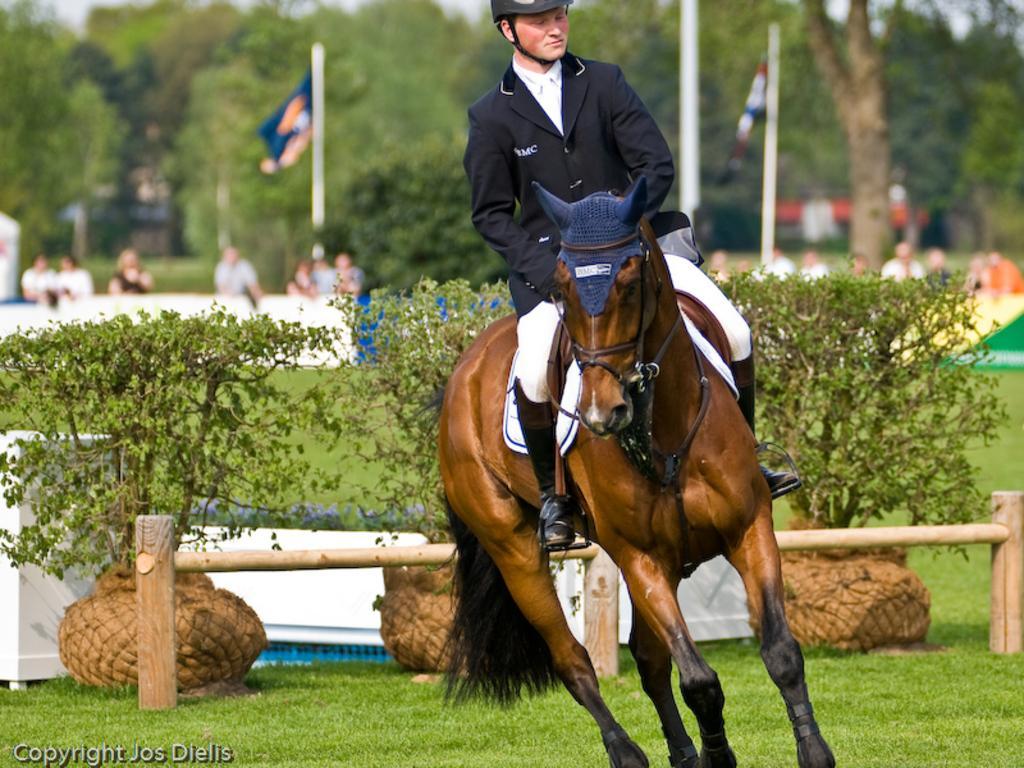Could you give a brief overview of what you see in this image? In this image, we can see a brown color horse, there is a man sitting on the horse and he is in black color coat, there are some green color plants, in the background we can see two flags, there are some people standing and there are some green color trees. 